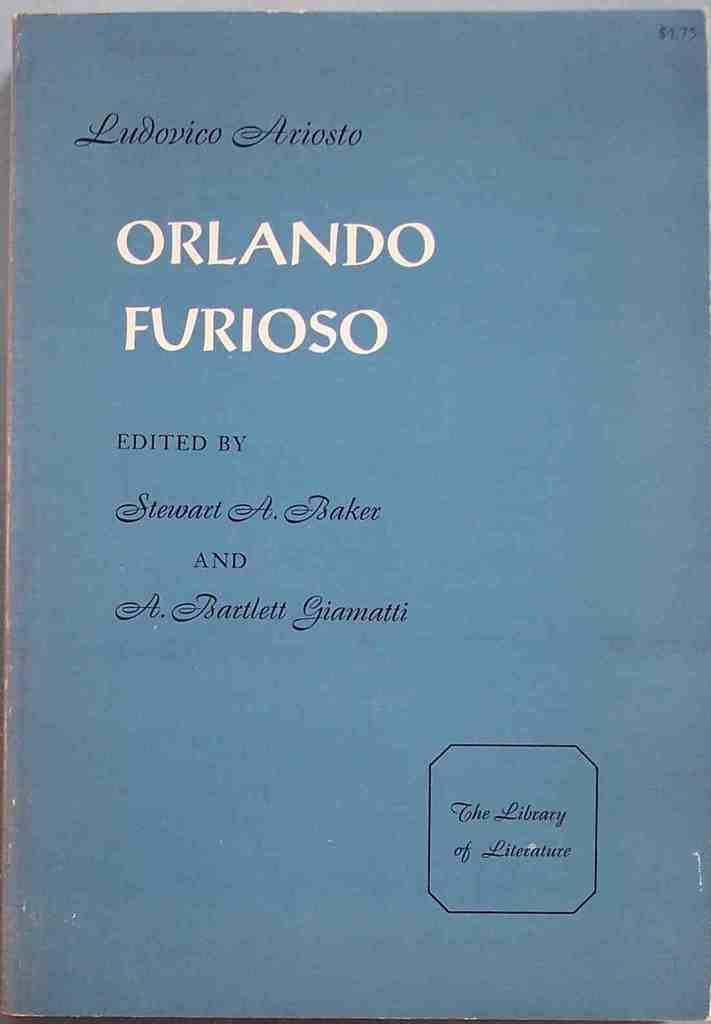Provide a one-sentence caption for the provided image. A copy of Orlando Furioso brought for $4.75. 